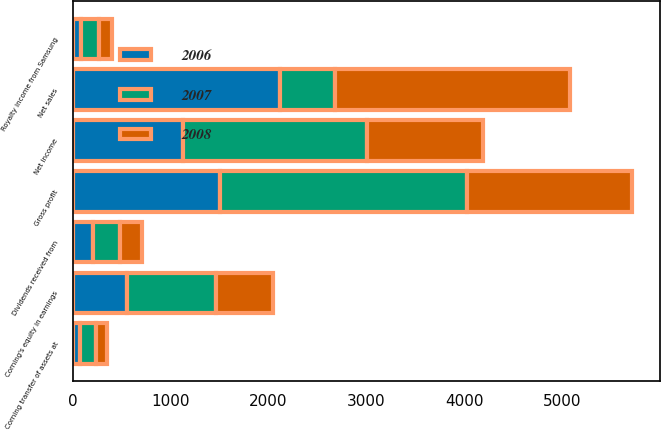Convert chart to OTSL. <chart><loc_0><loc_0><loc_500><loc_500><stacked_bar_chart><ecel><fcel>Net sales<fcel>Gross profit<fcel>Net income<fcel>Corning's equity in earnings<fcel>Corning transfer of assets at<fcel>Dividends received from<fcel>Royalty income from Samsung<nl><fcel>2007<fcel>568.5<fcel>2521<fcel>1874<fcel>911<fcel>173<fcel>278<fcel>184<nl><fcel>2008<fcel>2400<fcel>1681<fcel>1193<fcel>582<fcel>110<fcel>217<fcel>141<nl><fcel>2006<fcel>2115<fcel>1510<fcel>1128<fcel>555<fcel>71<fcel>210<fcel>82<nl></chart> 